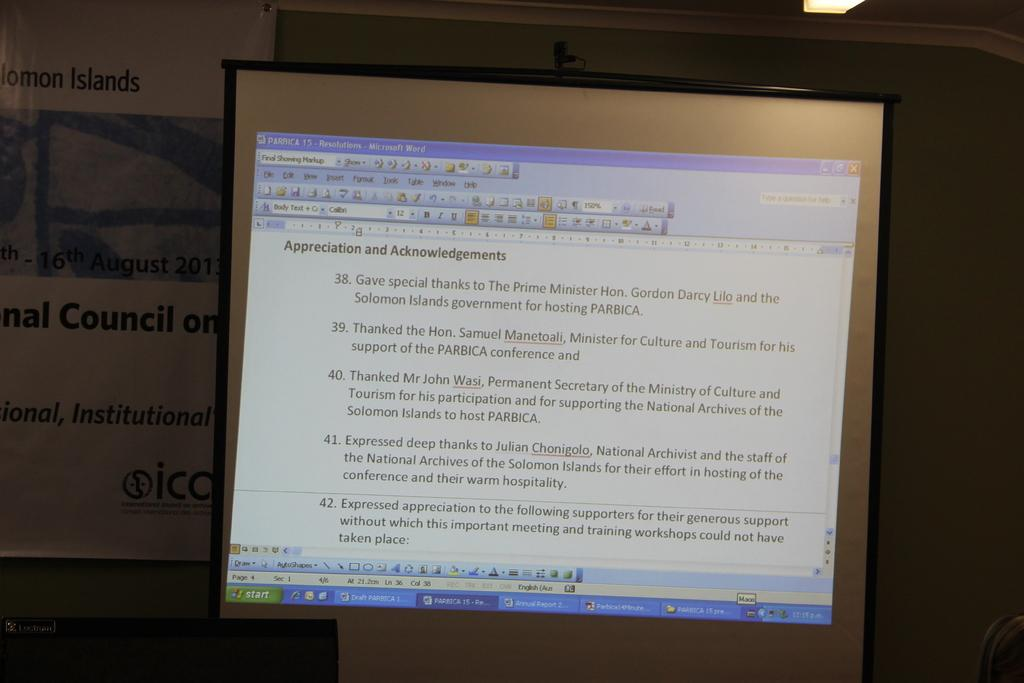<image>
Render a clear and concise summary of the photo. A computer screen is opened to a Word document with an Appreciation and Acknowledgements heading. 